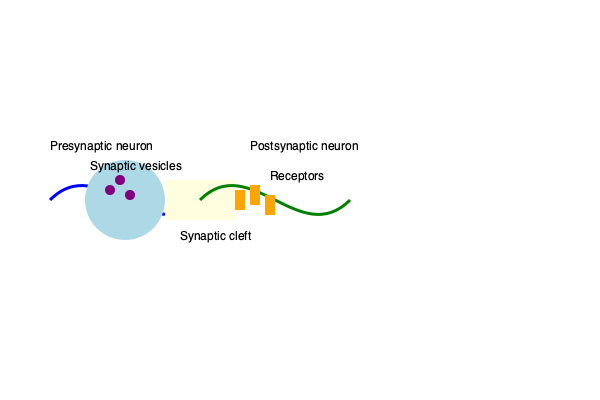As a science columnist preparing to host a neuroscientist for a community event, you want to ensure you understand the synaptic transmission process. Based on the illustration, what is the correct sequence of events in synaptic transmission, from the arrival of an action potential to the activation of the postsynaptic neuron? The synaptic transmission process occurs in the following sequence:

1. An action potential arrives at the presynaptic terminal (blue neuron).

2. The electrical signal causes voltage-gated calcium channels to open, allowing calcium ions to enter the presynaptic terminal.

3. The influx of calcium triggers synaptic vesicles (purple circles) to fuse with the presynaptic membrane.

4. This fusion causes the release of neurotransmitters into the synaptic cleft (yellow area between neurons).

5. Neurotransmitters diffuse across the synaptic cleft.

6. The neurotransmitters bind to specific receptors (orange rectangles) on the postsynaptic membrane (green neuron).

7. Binding of neurotransmitters causes ion channels to open or close, depending on the type of receptor.

8. This leads to a change in the membrane potential of the postsynaptic neuron, which may result in the generation of a new action potential or inhibition of the postsynaptic neuron.

9. Neurotransmitters are then either broken down by enzymes in the synaptic cleft or reabsorbed by the presynaptic neuron (reuptake) to terminate the signal.
Answer: Action potential arrival → Calcium influx → Vesicle fusion → Neurotransmitter release → Diffusion across cleft → Receptor binding → Postsynaptic potential change 